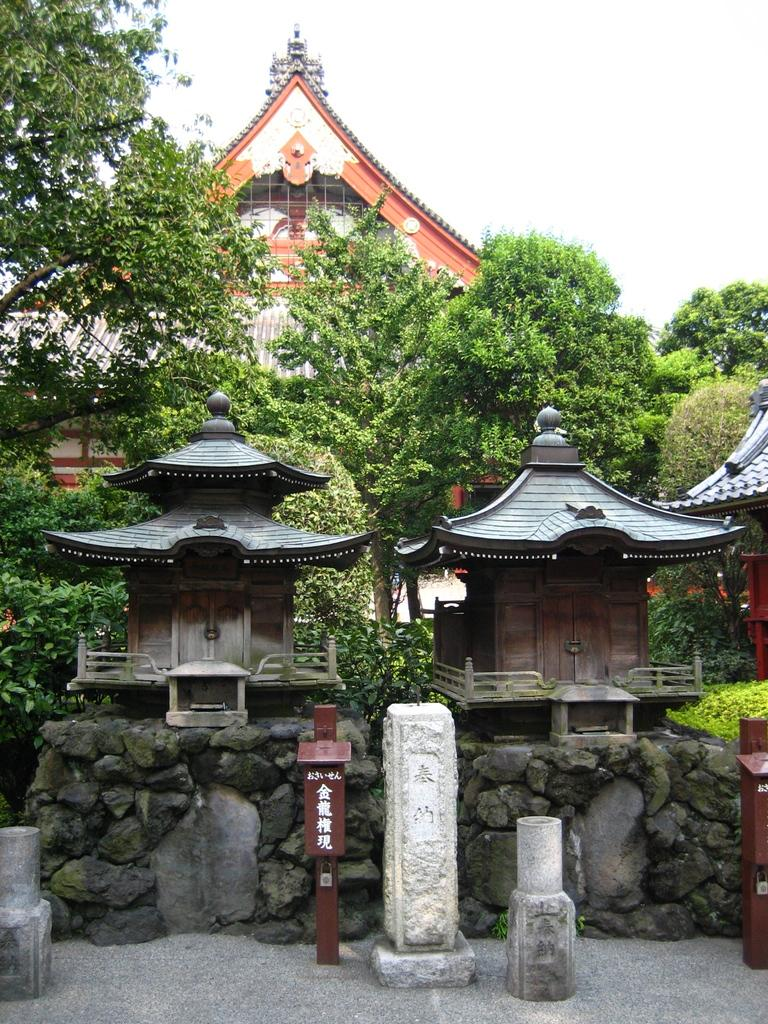What type of structures are present in the image? There are ancient architectures in the image. What features can be seen on these structures? There are doors visible on the ancient architectures. What other elements can be seen in the image? There are trees and a wall present in the image. What can be seen in the background of the image? The sky is visible in the background of the image. Can you see any fangs on the trees in the image? There are no fangs present on the trees in the image, as trees do not have fangs. Is there any fire visible in the image? There is no fire visible in the image. 